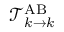<formula> <loc_0><loc_0><loc_500><loc_500>\mathcal { T } _ { k \rightarrow k } ^ { A B }</formula> 